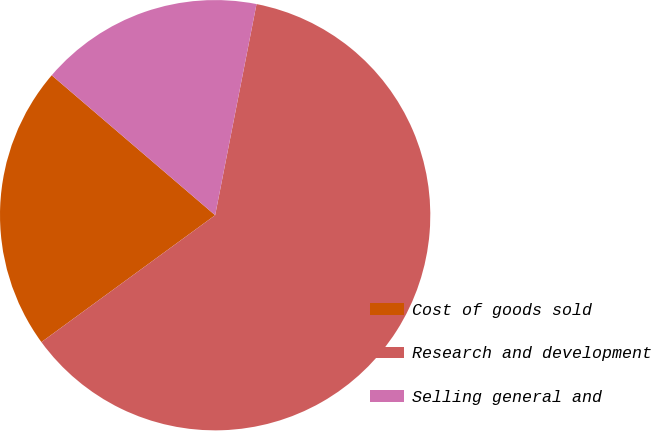Convert chart. <chart><loc_0><loc_0><loc_500><loc_500><pie_chart><fcel>Cost of goods sold<fcel>Research and development<fcel>Selling general and<nl><fcel>21.31%<fcel>61.88%<fcel>16.81%<nl></chart> 